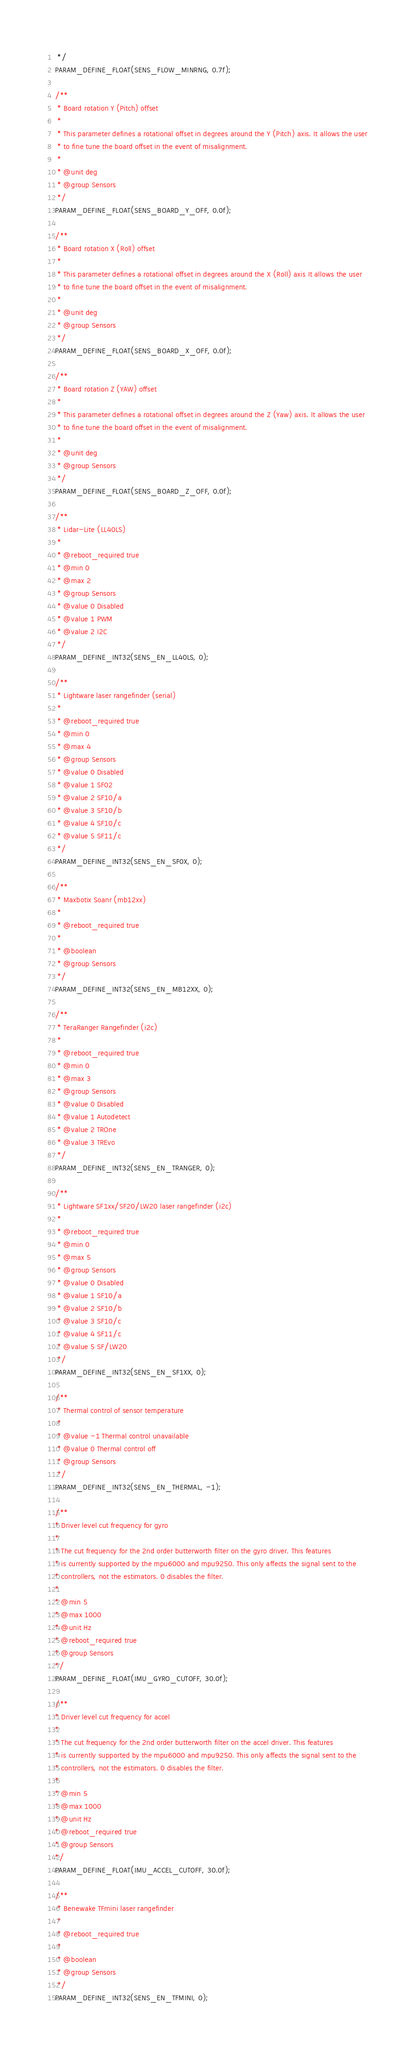<code> <loc_0><loc_0><loc_500><loc_500><_C_> */
PARAM_DEFINE_FLOAT(SENS_FLOW_MINRNG, 0.7f);

/**
 * Board rotation Y (Pitch) offset
 *
 * This parameter defines a rotational offset in degrees around the Y (Pitch) axis. It allows the user
 * to fine tune the board offset in the event of misalignment.
 *
 * @unit deg
 * @group Sensors
 */
PARAM_DEFINE_FLOAT(SENS_BOARD_Y_OFF, 0.0f);

/**
 * Board rotation X (Roll) offset
 *
 * This parameter defines a rotational offset in degrees around the X (Roll) axis It allows the user
 * to fine tune the board offset in the event of misalignment.
 *
 * @unit deg
 * @group Sensors
 */
PARAM_DEFINE_FLOAT(SENS_BOARD_X_OFF, 0.0f);

/**
 * Board rotation Z (YAW) offset
 *
 * This parameter defines a rotational offset in degrees around the Z (Yaw) axis. It allows the user
 * to fine tune the board offset in the event of misalignment.
 *
 * @unit deg
 * @group Sensors
 */
PARAM_DEFINE_FLOAT(SENS_BOARD_Z_OFF, 0.0f);

/**
 * Lidar-Lite (LL40LS)
 *
 * @reboot_required true
 * @min 0
 * @max 2
 * @group Sensors
 * @value 0 Disabled
 * @value 1 PWM
 * @value 2 I2C
 */
PARAM_DEFINE_INT32(SENS_EN_LL40LS, 0);

/**
 * Lightware laser rangefinder (serial)
 *
 * @reboot_required true
 * @min 0
 * @max 4
 * @group Sensors
 * @value 0 Disabled
 * @value 1 SF02
 * @value 2 SF10/a
 * @value 3 SF10/b
 * @value 4 SF10/c
 * @value 5 SF11/c
 */
PARAM_DEFINE_INT32(SENS_EN_SF0X, 0);

/**
 * Maxbotix Soanr (mb12xx)
 *
 * @reboot_required true
 *
 * @boolean
 * @group Sensors
 */
PARAM_DEFINE_INT32(SENS_EN_MB12XX, 0);

/**
 * TeraRanger Rangefinder (i2c)
 *
 * @reboot_required true
 * @min 0
 * @max 3
 * @group Sensors
 * @value 0 Disabled
 * @value 1 Autodetect
 * @value 2 TROne
 * @value 3 TREvo
 */
PARAM_DEFINE_INT32(SENS_EN_TRANGER, 0);

/**
 * Lightware SF1xx/SF20/LW20 laser rangefinder (i2c)
 *
 * @reboot_required true
 * @min 0
 * @max 5
 * @group Sensors
 * @value 0 Disabled
 * @value 1 SF10/a
 * @value 2 SF10/b
 * @value 3 SF10/c
 * @value 4 SF11/c
 * @value 5 SF/LW20
 */
PARAM_DEFINE_INT32(SENS_EN_SF1XX, 0);

/**
 * Thermal control of sensor temperature
 *
 * @value -1 Thermal control unavailable
 * @value 0 Thermal control off
 * @group Sensors
 */
PARAM_DEFINE_INT32(SENS_EN_THERMAL, -1);

/**
* Driver level cut frequency for gyro
*
* The cut frequency for the 2nd order butterworth filter on the gyro driver. This features
* is currently supported by the mpu6000 and mpu9250. This only affects the signal sent to the
* controllers, not the estimators. 0 disables the filter.
*
* @min 5
* @max 1000
* @unit Hz
* @reboot_required true
* @group Sensors
*/
PARAM_DEFINE_FLOAT(IMU_GYRO_CUTOFF, 30.0f);

/**
* Driver level cut frequency for accel
*
* The cut frequency for the 2nd order butterworth filter on the accel driver. This features
* is currently supported by the mpu6000 and mpu9250. This only affects the signal sent to the
* controllers, not the estimators. 0 disables the filter.
*
* @min 5
* @max 1000
* @unit Hz
* @reboot_required true
* @group Sensors
*/
PARAM_DEFINE_FLOAT(IMU_ACCEL_CUTOFF, 30.0f);

/**
 * Benewake TFmini laser rangefinder
 *
 * @reboot_required true
 *
 * @boolean
 * @group Sensors
 */
PARAM_DEFINE_INT32(SENS_EN_TFMINI, 0);
</code> 